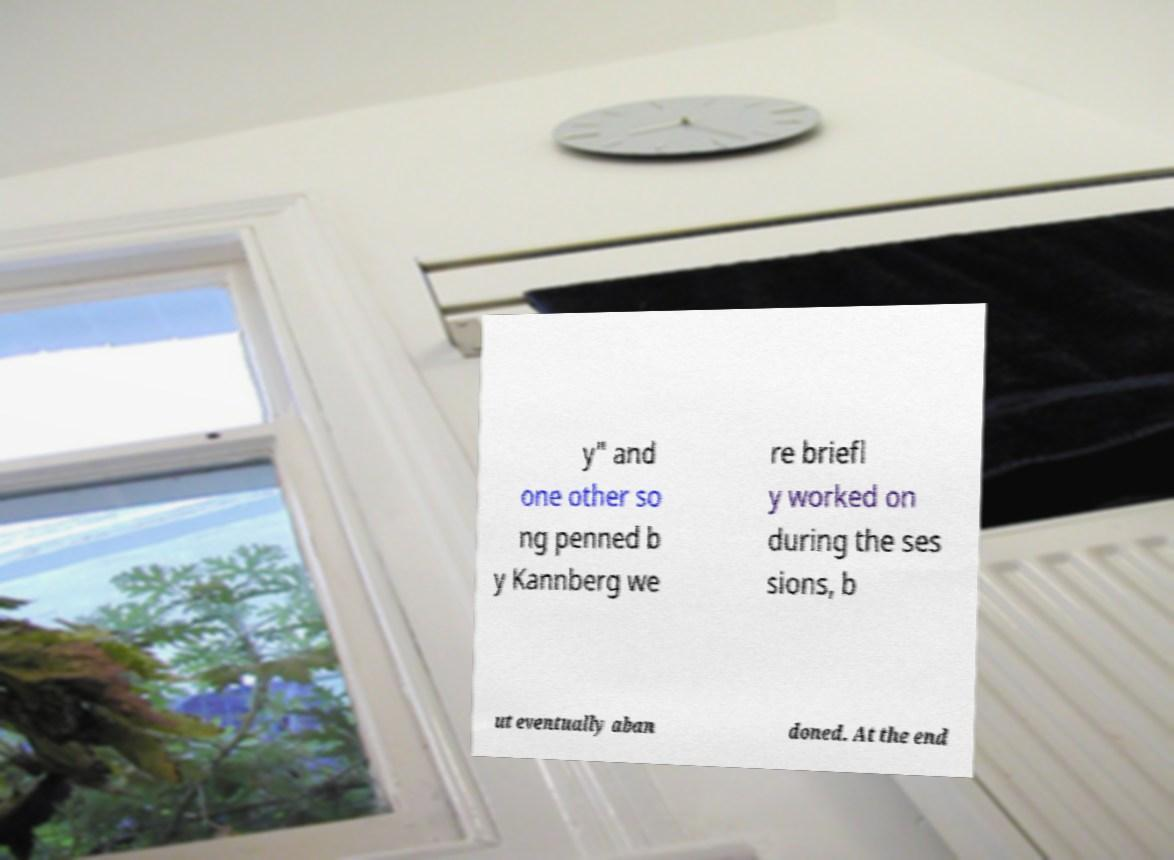What messages or text are displayed in this image? I need them in a readable, typed format. y" and one other so ng penned b y Kannberg we re briefl y worked on during the ses sions, b ut eventually aban doned. At the end 